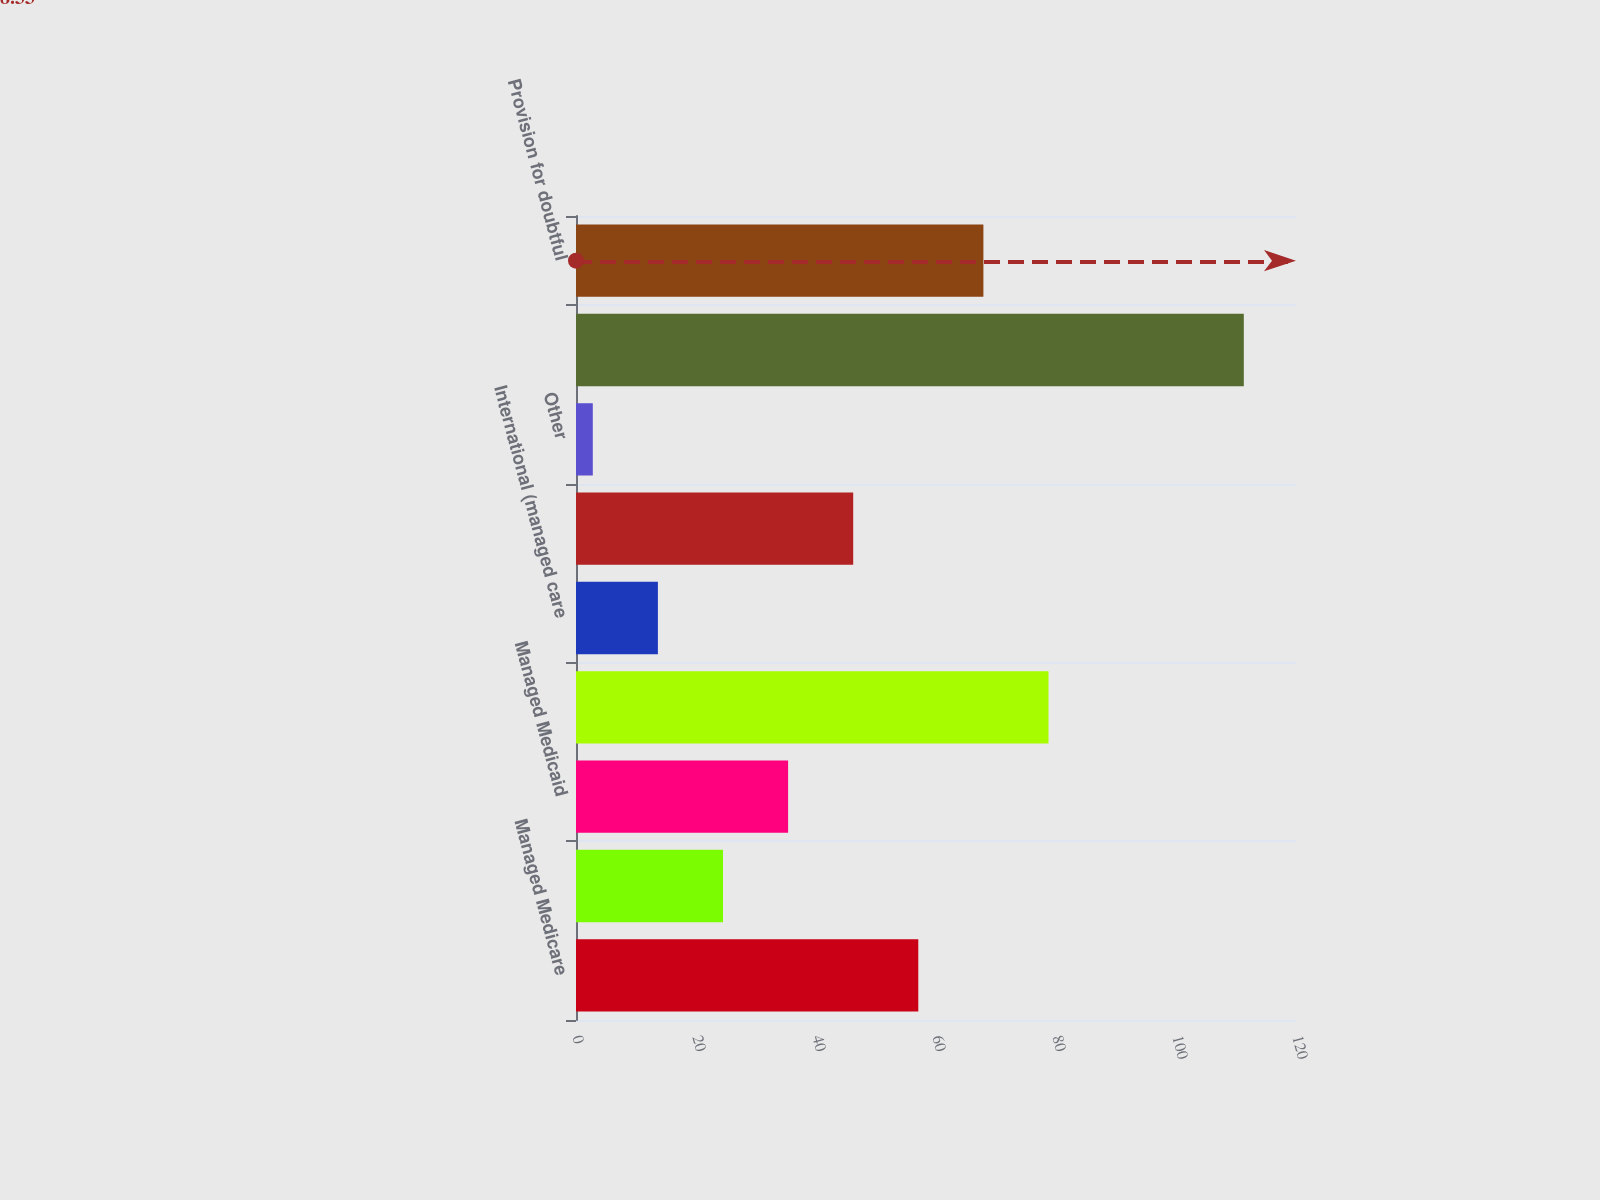<chart> <loc_0><loc_0><loc_500><loc_500><bar_chart><fcel>Managed Medicare<fcel>Medicaid<fcel>Managed Medicaid<fcel>Managed care and other<fcel>International (managed care<fcel>Uninsured<fcel>Other<fcel>Revenues before provision for<fcel>Provision for doubtful<nl><fcel>57.05<fcel>24.5<fcel>35.35<fcel>78.75<fcel>13.65<fcel>46.2<fcel>2.8<fcel>111.3<fcel>67.9<nl></chart> 